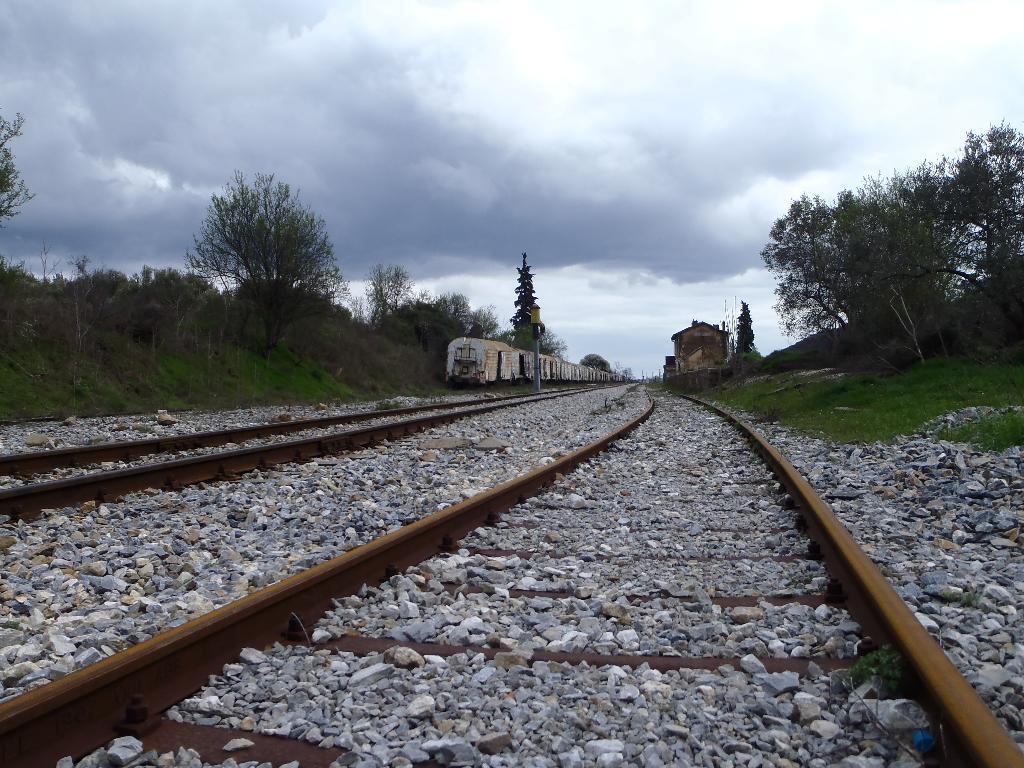Please provide a concise description of this image. At the bottom of the picture, we see the concrete stones and the railway tracks. On the right side, we see the grass, trees and a building. In the middle, we see a pole. There are trees and building in the background. At the top, we see the sky and the clouds. 